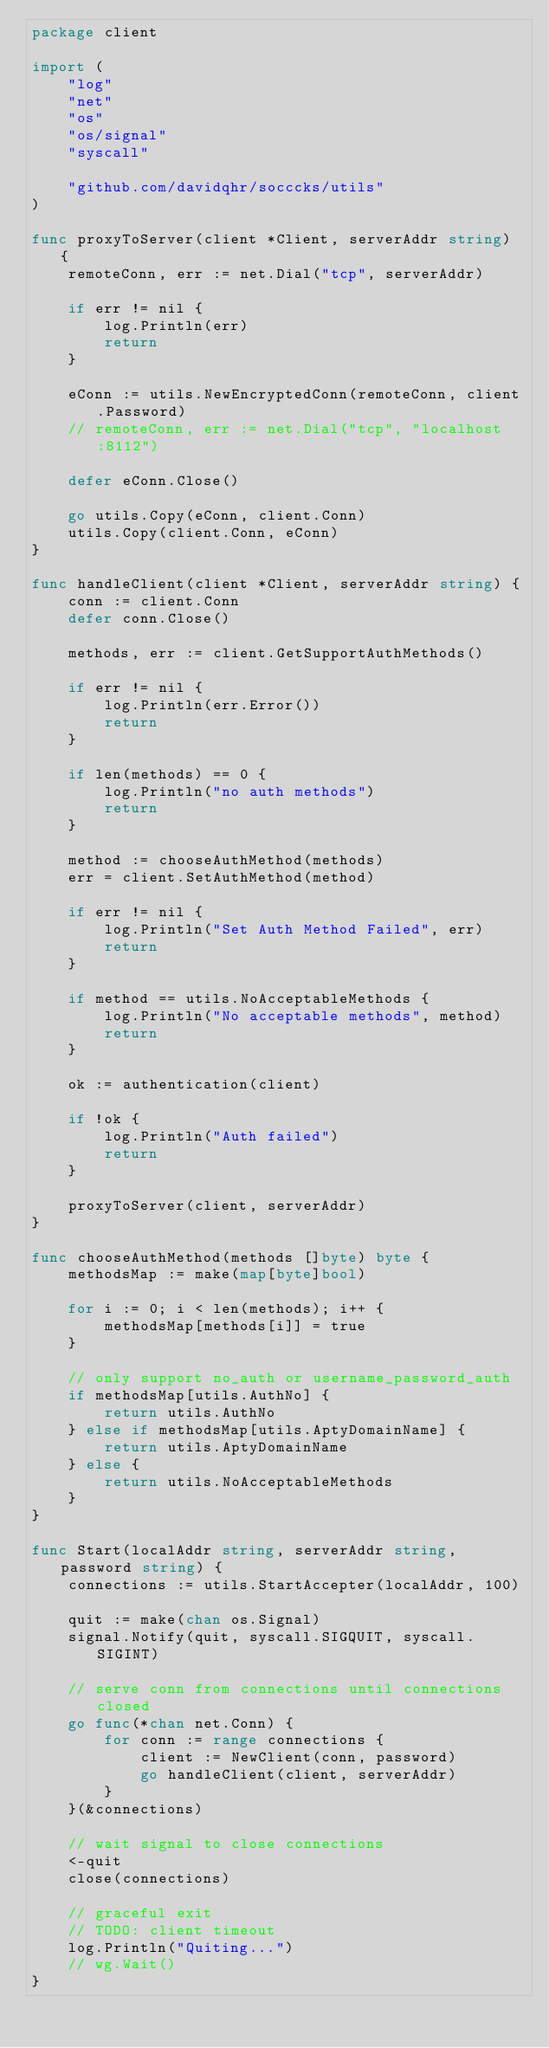<code> <loc_0><loc_0><loc_500><loc_500><_Go_>package client

import (
	"log"
	"net"
	"os"
	"os/signal"
	"syscall"

	"github.com/davidqhr/socccks/utils"
)

func proxyToServer(client *Client, serverAddr string) {
	remoteConn, err := net.Dial("tcp", serverAddr)

	if err != nil {
		log.Println(err)
		return
	}

	eConn := utils.NewEncryptedConn(remoteConn, client.Password)
	// remoteConn, err := net.Dial("tcp", "localhost:8112")

	defer eConn.Close()

	go utils.Copy(eConn, client.Conn)
	utils.Copy(client.Conn, eConn)
}

func handleClient(client *Client, serverAddr string) {
	conn := client.Conn
	defer conn.Close()

	methods, err := client.GetSupportAuthMethods()

	if err != nil {
		log.Println(err.Error())
		return
	}

	if len(methods) == 0 {
		log.Println("no auth methods")
		return
	}

	method := chooseAuthMethod(methods)
	err = client.SetAuthMethod(method)

	if err != nil {
		log.Println("Set Auth Method Failed", err)
		return
	}

	if method == utils.NoAcceptableMethods {
		log.Println("No acceptable methods", method)
		return
	}

	ok := authentication(client)

	if !ok {
		log.Println("Auth failed")
		return
	}

	proxyToServer(client, serverAddr)
}

func chooseAuthMethod(methods []byte) byte {
	methodsMap := make(map[byte]bool)

	for i := 0; i < len(methods); i++ {
		methodsMap[methods[i]] = true
	}

	// only support no_auth or username_password_auth
	if methodsMap[utils.AuthNo] {
		return utils.AuthNo
	} else if methodsMap[utils.AptyDomainName] {
		return utils.AptyDomainName
	} else {
		return utils.NoAcceptableMethods
	}
}

func Start(localAddr string, serverAddr string, password string) {
	connections := utils.StartAccepter(localAddr, 100)

	quit := make(chan os.Signal)
	signal.Notify(quit, syscall.SIGQUIT, syscall.SIGINT)

	// serve conn from connections until connections closed
	go func(*chan net.Conn) {
		for conn := range connections {
			client := NewClient(conn, password)
			go handleClient(client, serverAddr)
		}
	}(&connections)

	// wait signal to close connections
	<-quit
	close(connections)

	// graceful exit
	// TODO: client timeout
	log.Println("Quiting...")
	// wg.Wait()
}
</code> 